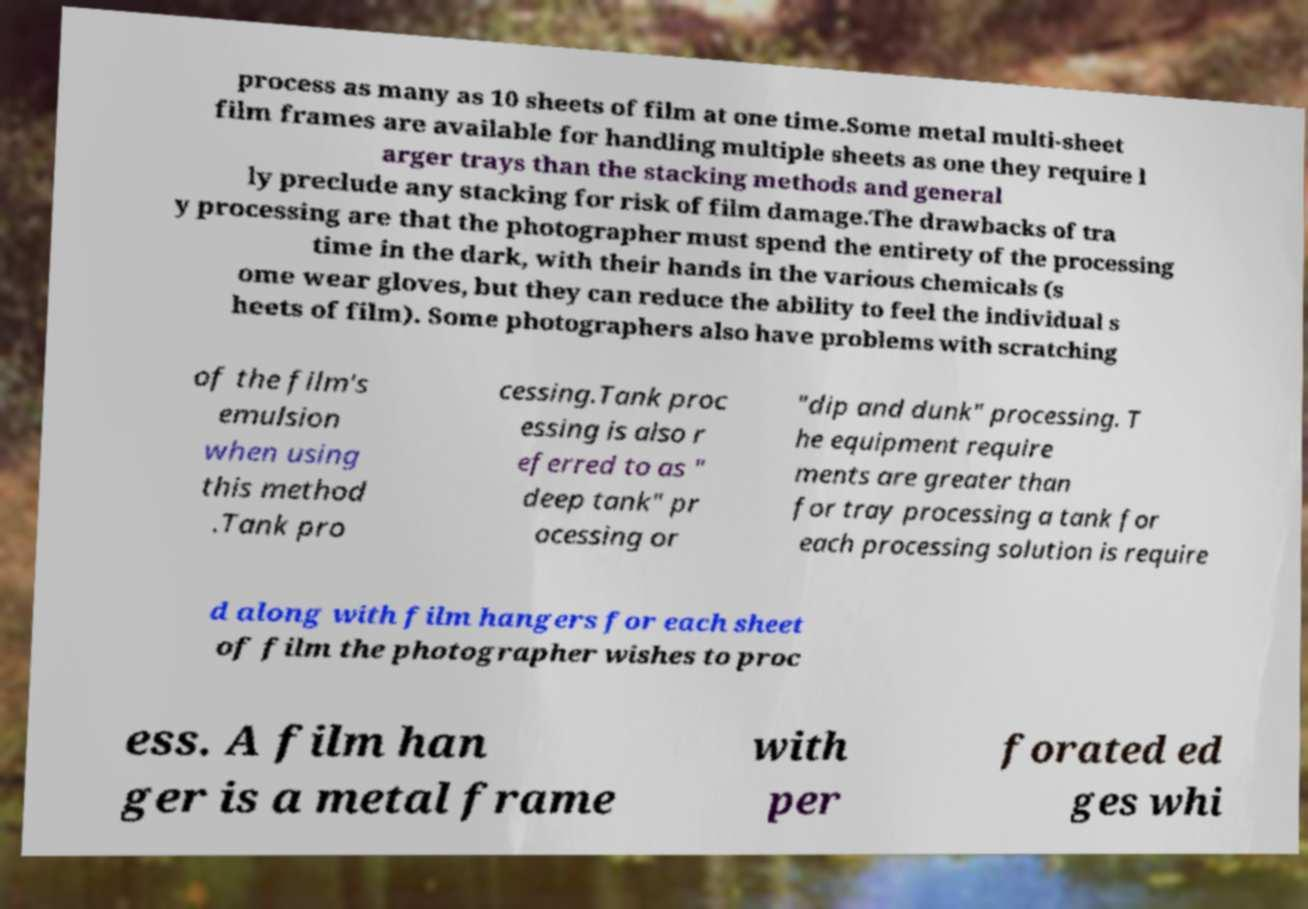Can you accurately transcribe the text from the provided image for me? process as many as 10 sheets of film at one time.Some metal multi-sheet film frames are available for handling multiple sheets as one they require l arger trays than the stacking methods and general ly preclude any stacking for risk of film damage.The drawbacks of tra y processing are that the photographer must spend the entirety of the processing time in the dark, with their hands in the various chemicals (s ome wear gloves, but they can reduce the ability to feel the individual s heets of film). Some photographers also have problems with scratching of the film's emulsion when using this method .Tank pro cessing.Tank proc essing is also r eferred to as " deep tank" pr ocessing or "dip and dunk" processing. T he equipment require ments are greater than for tray processing a tank for each processing solution is require d along with film hangers for each sheet of film the photographer wishes to proc ess. A film han ger is a metal frame with per forated ed ges whi 